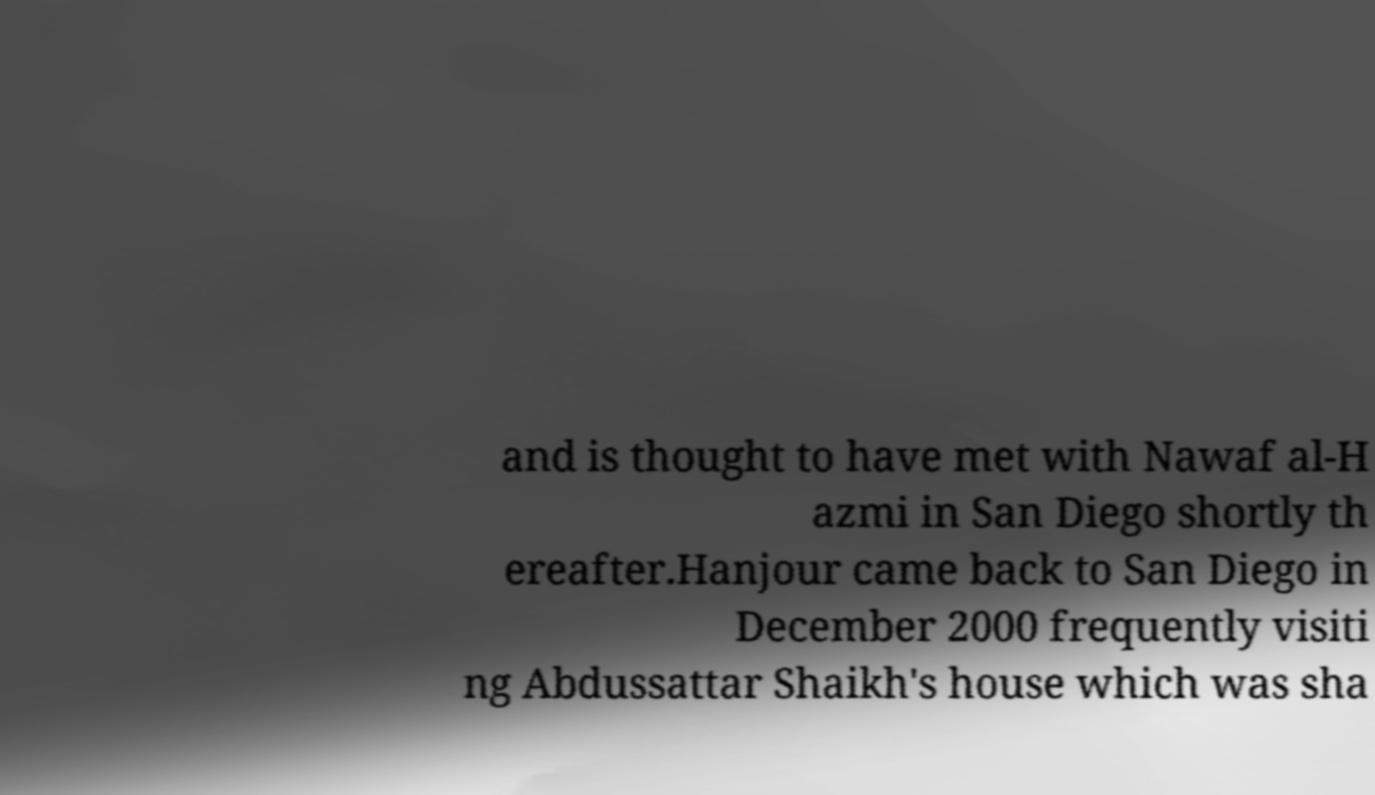Could you assist in decoding the text presented in this image and type it out clearly? and is thought to have met with Nawaf al-H azmi in San Diego shortly th ereafter.Hanjour came back to San Diego in December 2000 frequently visiti ng Abdussattar Shaikh's house which was sha 